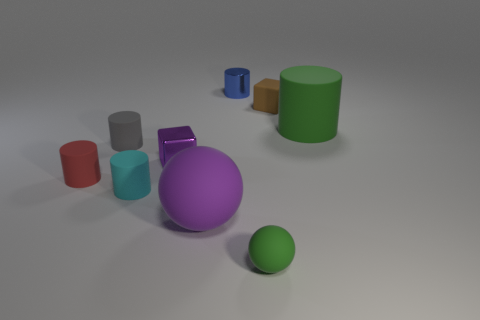Are there the same number of tiny rubber blocks that are behind the small red object and tiny green matte objects?
Make the answer very short. Yes. There is a cube to the left of the green rubber object that is in front of the small cube left of the small green thing; what is it made of?
Make the answer very short. Metal. Are there any purple blocks of the same size as the cyan matte object?
Offer a terse response. Yes. What shape is the large purple rubber object?
Make the answer very short. Sphere. How many spheres are blue rubber things or tiny blue metal things?
Offer a very short reply. 0. Is the number of small rubber balls that are in front of the small rubber sphere the same as the number of tiny gray rubber objects that are left of the small gray cylinder?
Make the answer very short. Yes. There is a rubber cylinder that is to the right of the green rubber thing in front of the purple metallic object; how many small blue metal cylinders are in front of it?
Give a very brief answer. 0. There is a rubber object that is the same color as the small ball; what is its shape?
Keep it short and to the point. Cylinder. Is the color of the small rubber ball the same as the large rubber thing that is behind the gray matte object?
Ensure brevity in your answer.  Yes. Are there more large purple things on the left side of the green ball than tiny blue metal balls?
Offer a terse response. Yes. 